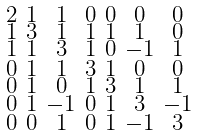<formula> <loc_0><loc_0><loc_500><loc_500>\begin{smallmatrix} 2 & 1 & 1 & 0 & 0 & 0 & 0 \\ 1 & 3 & 1 & 1 & 1 & 1 & 0 \\ 1 & 1 & 3 & 1 & 0 & - 1 & 1 \\ 0 & 1 & 1 & 3 & 1 & 0 & 0 \\ 0 & 1 & 0 & 1 & 3 & 1 & 1 \\ 0 & 1 & - 1 & 0 & 1 & 3 & - 1 \\ 0 & 0 & 1 & 0 & 1 & - 1 & 3 \end{smallmatrix}</formula> 